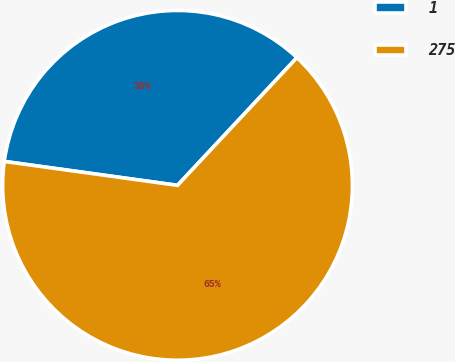Convert chart to OTSL. <chart><loc_0><loc_0><loc_500><loc_500><pie_chart><fcel>1<fcel>275<nl><fcel>34.78%<fcel>65.22%<nl></chart> 